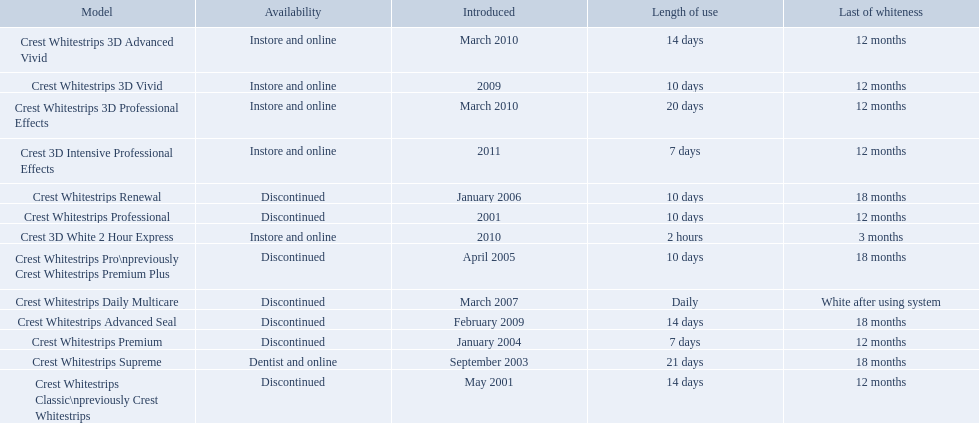What types of crest whitestrips have been released? Crest Whitestrips Classic\npreviously Crest Whitestrips, Crest Whitestrips Professional, Crest Whitestrips Supreme, Crest Whitestrips Premium, Crest Whitestrips Pro\npreviously Crest Whitestrips Premium Plus, Crest Whitestrips Renewal, Crest Whitestrips Daily Multicare, Crest Whitestrips Advanced Seal, Crest Whitestrips 3D Vivid, Crest Whitestrips 3D Advanced Vivid, Crest Whitestrips 3D Professional Effects, Crest 3D White 2 Hour Express, Crest 3D Intensive Professional Effects. What was the length of use for each type? 14 days, 10 days, 21 days, 7 days, 10 days, 10 days, Daily, 14 days, 10 days, 14 days, 20 days, 2 hours, 7 days. And how long did each last? 12 months, 12 months, 18 months, 12 months, 18 months, 18 months, White after using system, 18 months, 12 months, 12 months, 12 months, 3 months, 12 months. Of those models, which lasted the longest with the longest length of use? Crest Whitestrips Supreme. 